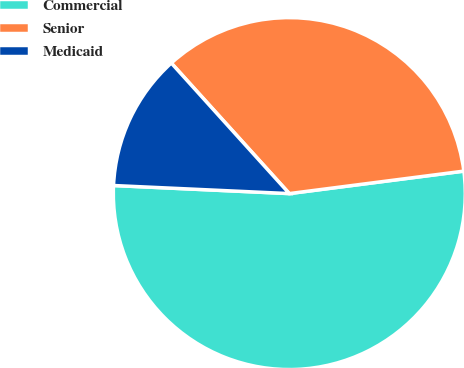Convert chart. <chart><loc_0><loc_0><loc_500><loc_500><pie_chart><fcel>Commercial<fcel>Senior<fcel>Medicaid<nl><fcel>52.77%<fcel>34.66%<fcel>12.57%<nl></chart> 